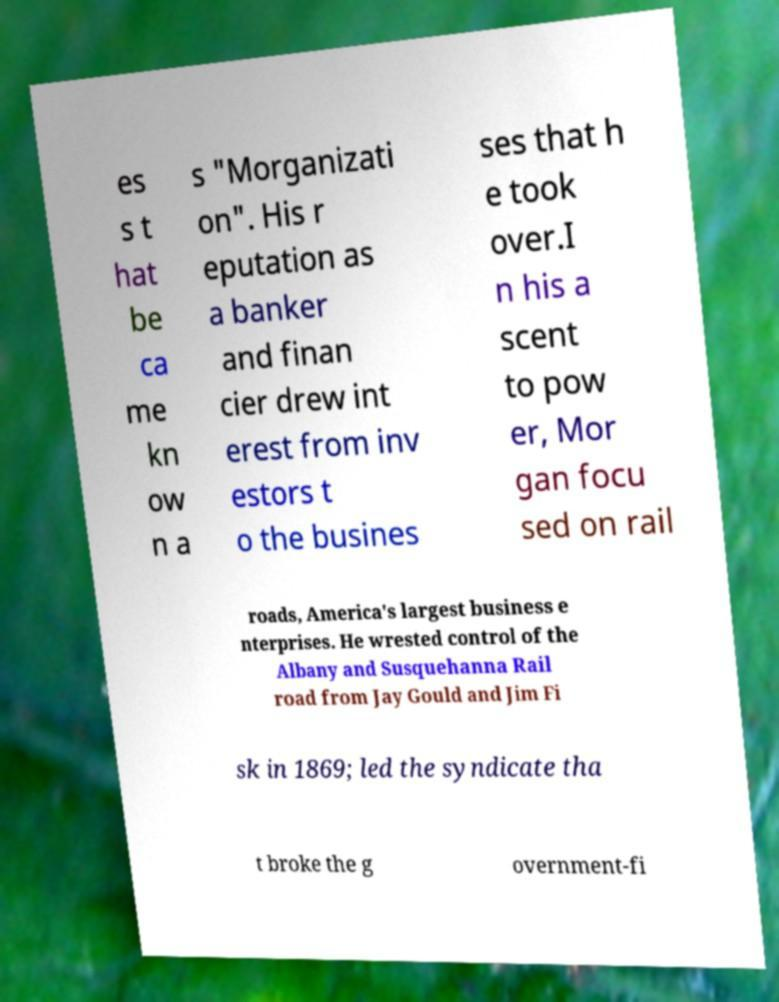Can you read and provide the text displayed in the image?This photo seems to have some interesting text. Can you extract and type it out for me? es s t hat be ca me kn ow n a s "Morganizati on". His r eputation as a banker and finan cier drew int erest from inv estors t o the busines ses that h e took over.I n his a scent to pow er, Mor gan focu sed on rail roads, America's largest business e nterprises. He wrested control of the Albany and Susquehanna Rail road from Jay Gould and Jim Fi sk in 1869; led the syndicate tha t broke the g overnment-fi 